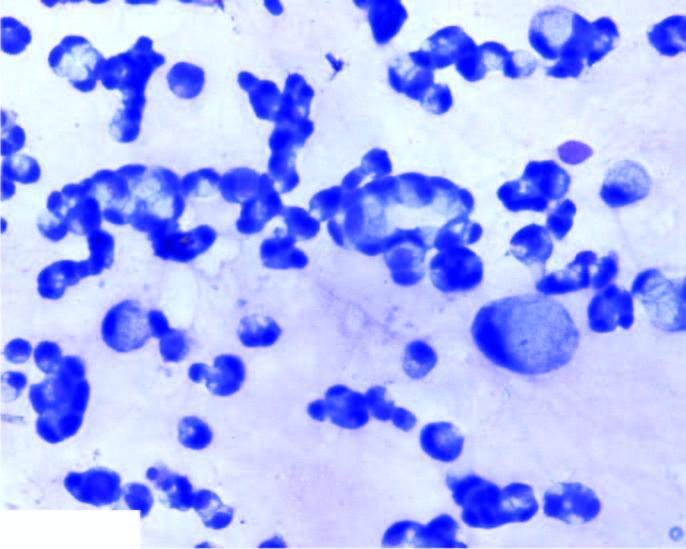re there large number of malignant cells scattered singly or in small clusters having characteristic cytoplasmic vacuoles, nuclear hyperchromasia and prominent nucleoli?
Answer the question using a single word or phrase. Yes 